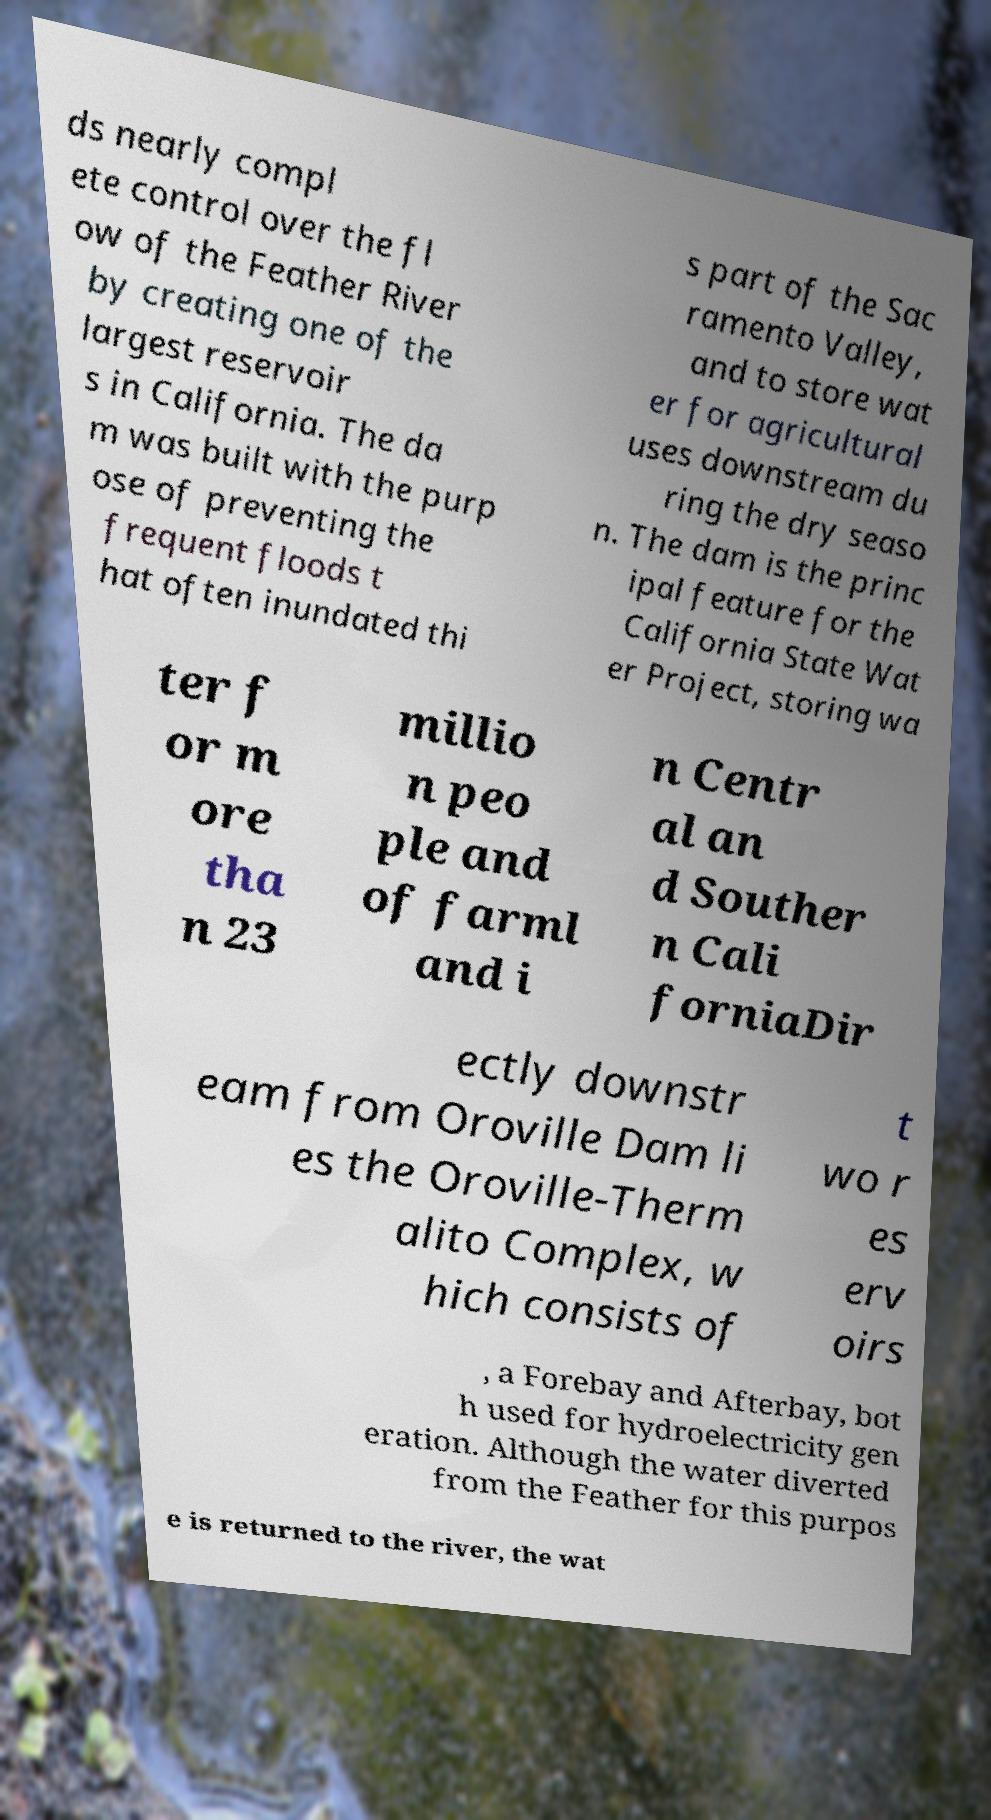Can you accurately transcribe the text from the provided image for me? ds nearly compl ete control over the fl ow of the Feather River by creating one of the largest reservoir s in California. The da m was built with the purp ose of preventing the frequent floods t hat often inundated thi s part of the Sac ramento Valley, and to store wat er for agricultural uses downstream du ring the dry seaso n. The dam is the princ ipal feature for the California State Wat er Project, storing wa ter f or m ore tha n 23 millio n peo ple and of farml and i n Centr al an d Souther n Cali forniaDir ectly downstr eam from Oroville Dam li es the Oroville-Therm alito Complex, w hich consists of t wo r es erv oirs , a Forebay and Afterbay, bot h used for hydroelectricity gen eration. Although the water diverted from the Feather for this purpos e is returned to the river, the wat 